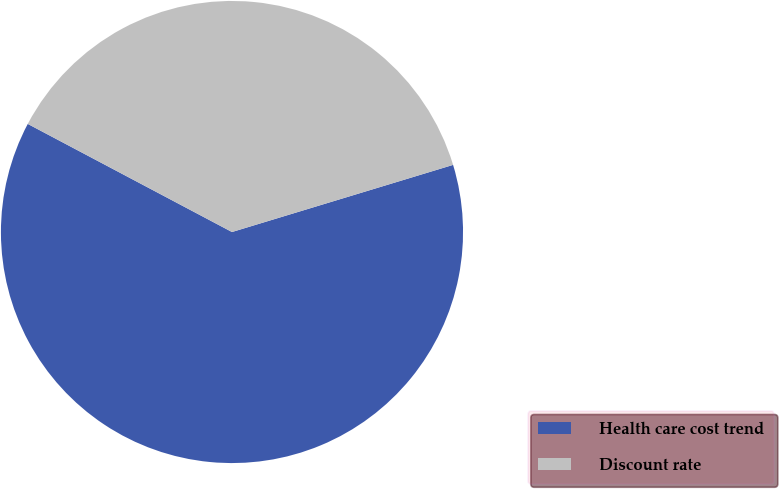<chart> <loc_0><loc_0><loc_500><loc_500><pie_chart><fcel>Health care cost trend<fcel>Discount rate<nl><fcel>62.44%<fcel>37.56%<nl></chart> 